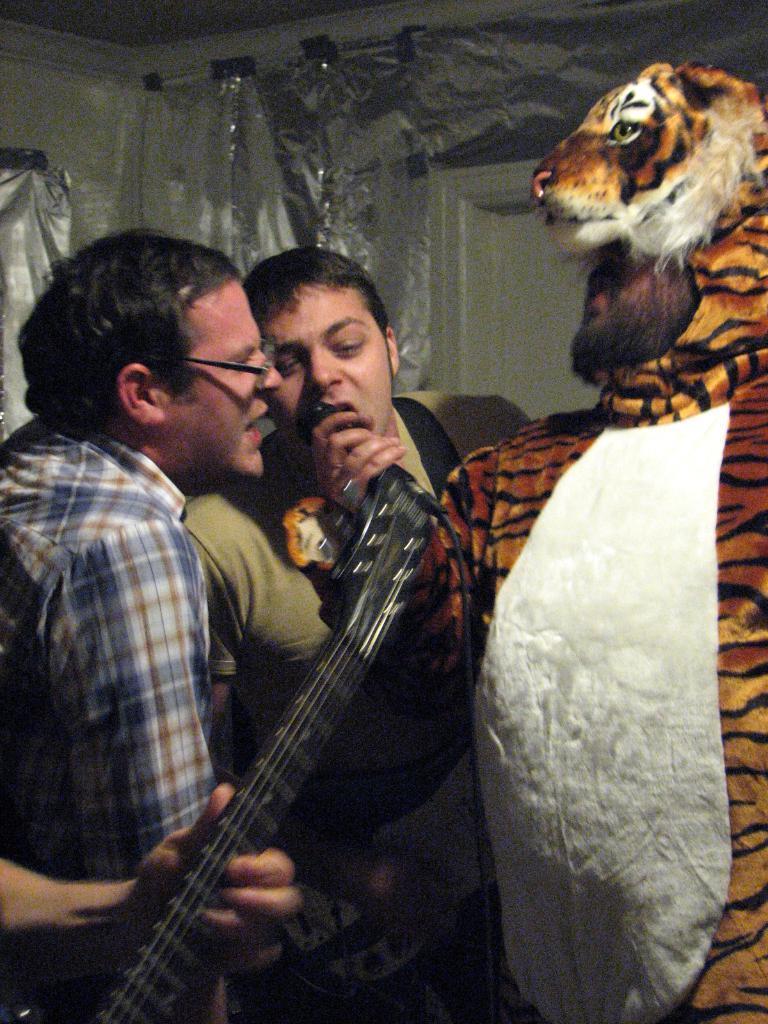Could you give a brief overview of what you see in this image? In this image two persons standing are singing. Person at the right side is wearing a tiger dress is holding a mike in his hand. At the left bottom there is a person hand holding a guitar. 